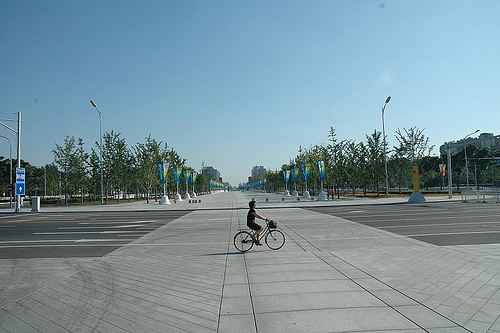<image>
Can you confirm if the bicycle is on the road? Yes. Looking at the image, I can see the bicycle is positioned on top of the road, with the road providing support. 